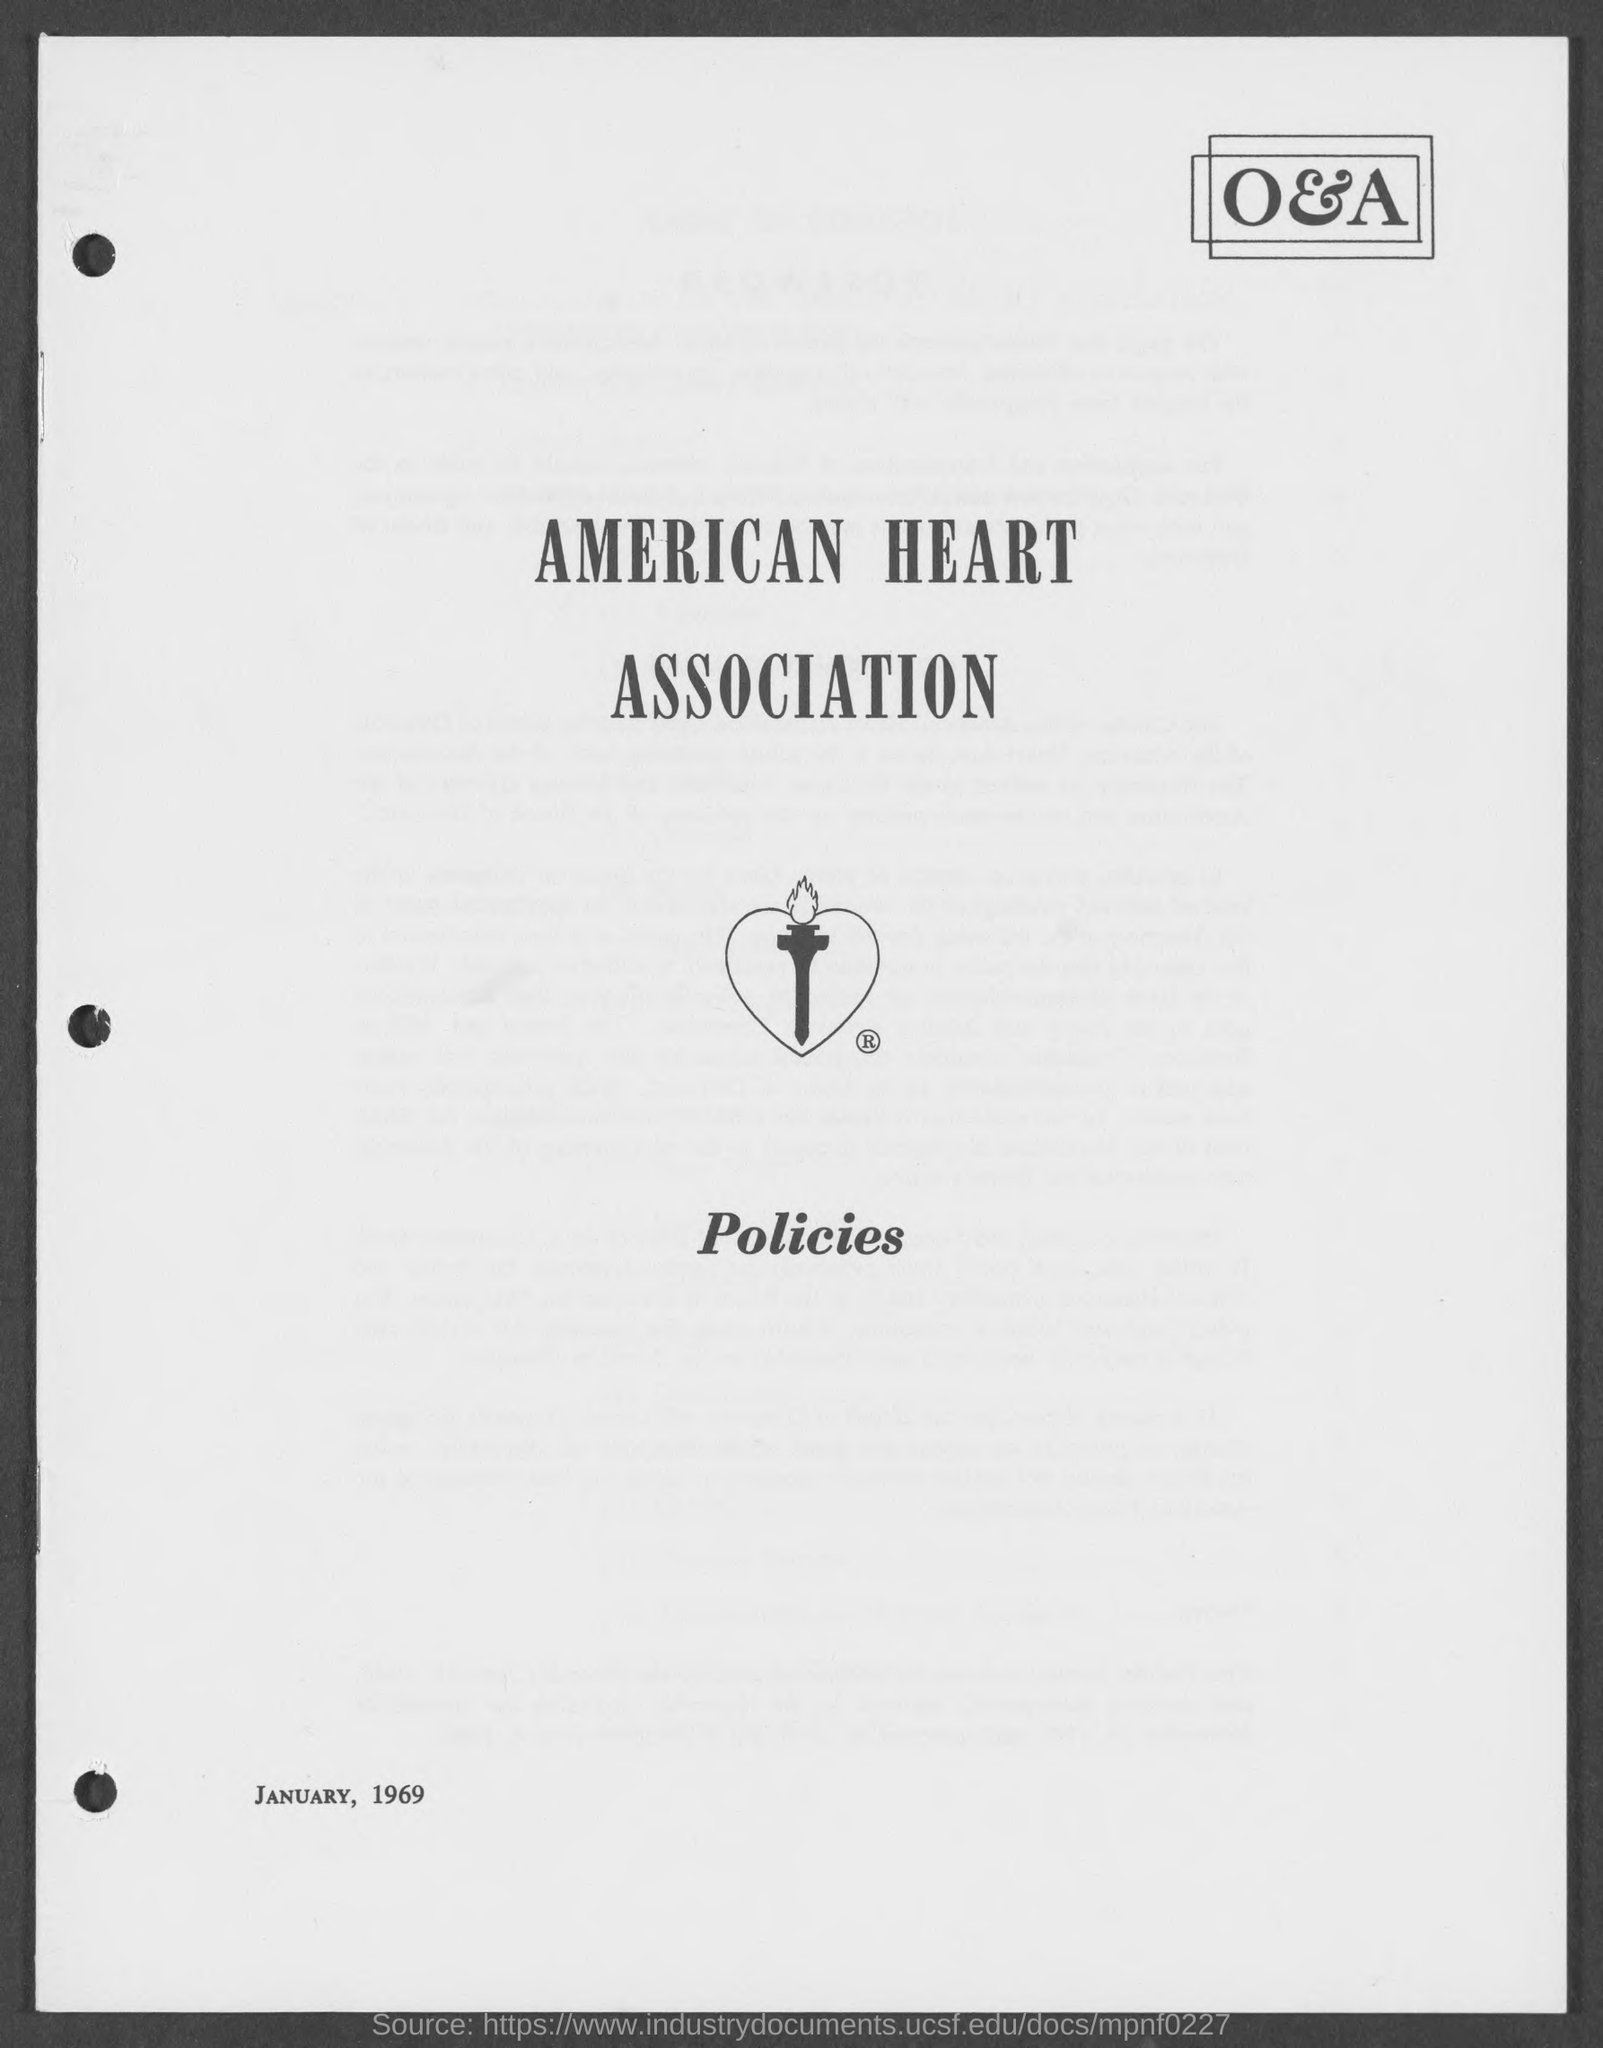What is the name of heart association ?
Your answer should be very brief. American Heart Association. 